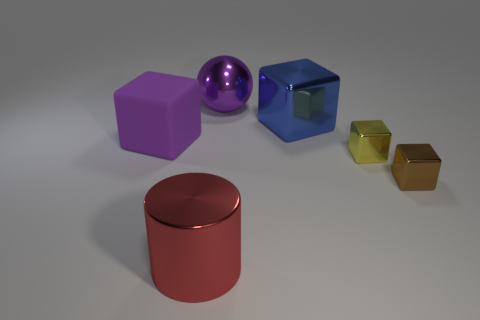Subtract 1 cubes. How many cubes are left? 3 Add 3 small cubes. How many objects exist? 9 Subtract all cubes. How many objects are left? 2 Subtract all metallic cylinders. Subtract all brown blocks. How many objects are left? 4 Add 2 big metallic cylinders. How many big metallic cylinders are left? 3 Add 5 tiny red metallic things. How many tiny red metallic things exist? 5 Subtract 0 gray cylinders. How many objects are left? 6 